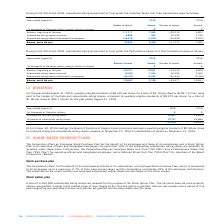According to Cogeco's financial document, What was the eligible quarterly dividends in August 2019? According to the financial document, $0.525. The relevant text states: "d August 31, 2019, quarterly eligible dividends of $0.525 per share, for a total of $2.10 per share or $103.7 million, were paid to the holders of multiple an..." Also, What was the eligible quarterly dividends in August 2018? According to the financial document, $0.475. The relevant text states: "hares, compared to quarterly eligible dividends of $0.475 per share, for a total of $1.90 per share or $93.7 million for the year ended August 31, 2018...." Also, What was the declared quarterly dividend for multiple voting and subordinate voting shares in 2019? According to the financial document, $0.58. The relevant text states: "ications declared a quarterly eligible dividend of $0.58 per share for multiple voting and subordinate voting shares, payable on November 27, 2019 to shareho..." Also, can you calculate: What was the increase / (decrease) in the Dividends on multiple voting shares from 2018 to 2019? Based on the calculation: 32,951 - 29,813, the result is 3138 (in thousands). This is based on the information: "Dividends on multiple voting shares 32,951 29,813 Dividends on multiple voting shares 32,951 29,813..." The key data points involved are: 29,813, 32,951. Also, can you calculate: What was the average Dividends on subordinate voting shares from 2018 to 2019? To answer this question, I need to perform calculations using the financial data. The calculation is: (70,757 + 63,886) / 2, which equals 67321.5 (in thousands). This is based on the information: "Dividends on subordinate voting shares 70,757 63,886 Dividends on subordinate voting shares 70,757 63,886..." The key data points involved are: 63,886, 70,757. Also, can you calculate: What was the average Dividends on multiple voting shares from 2018 to 2019? To answer this question, I need to perform calculations using the financial data. The calculation is: (32,951 + 29,813) / 2, which equals 31382 (in thousands). This is based on the information: "Dividends on multiple voting shares 32,951 29,813 Dividends on multiple voting shares 32,951 29,813..." The key data points involved are: 29,813, 32,951. 